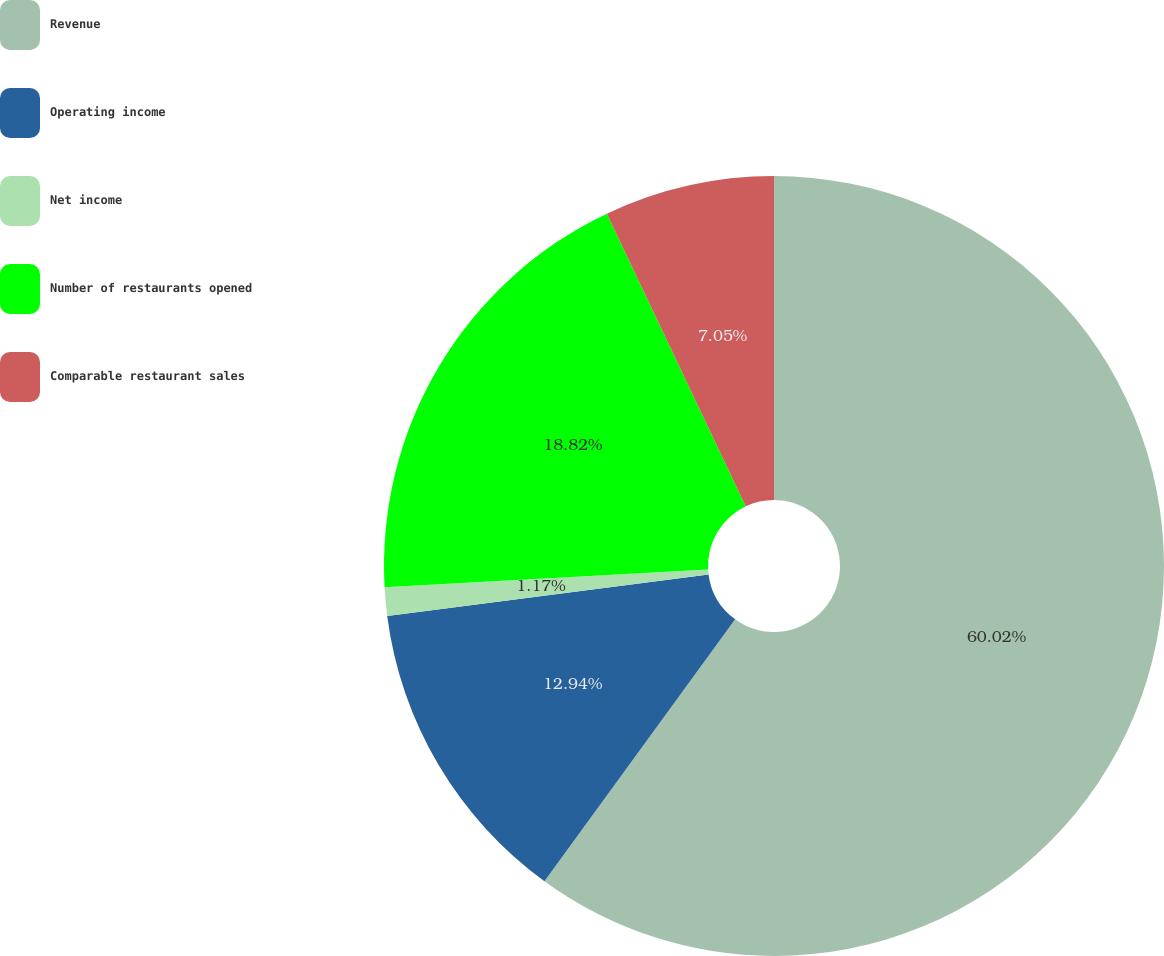<chart> <loc_0><loc_0><loc_500><loc_500><pie_chart><fcel>Revenue<fcel>Operating income<fcel>Net income<fcel>Number of restaurants opened<fcel>Comparable restaurant sales<nl><fcel>60.01%<fcel>12.94%<fcel>1.17%<fcel>18.82%<fcel>7.05%<nl></chart> 